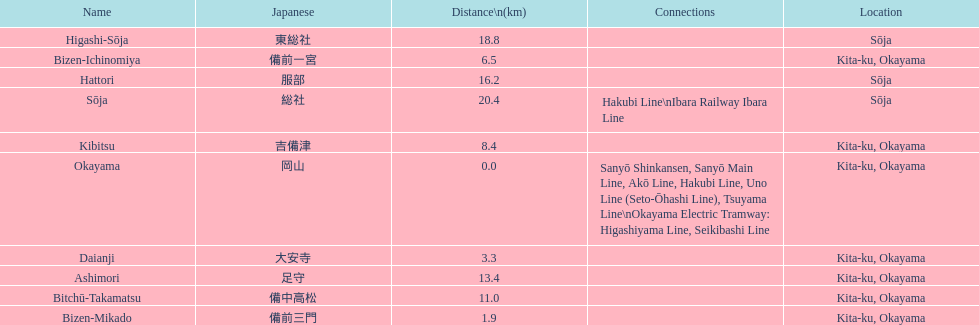Which has a distance less than 3.0 kilometers? Bizen-Mikado. 